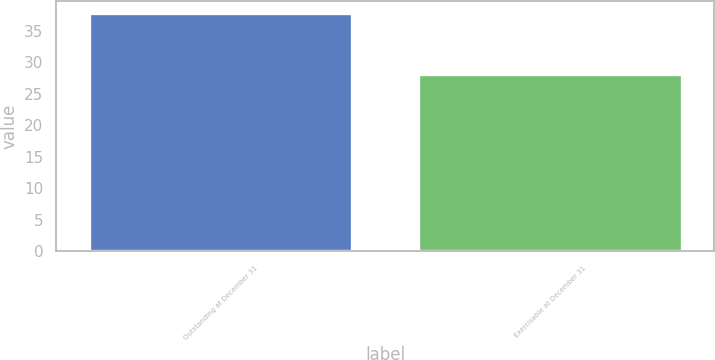Convert chart to OTSL. <chart><loc_0><loc_0><loc_500><loc_500><bar_chart><fcel>Outstanding at December 31<fcel>Exercisable at December 31<nl><fcel>37.77<fcel>28.06<nl></chart> 